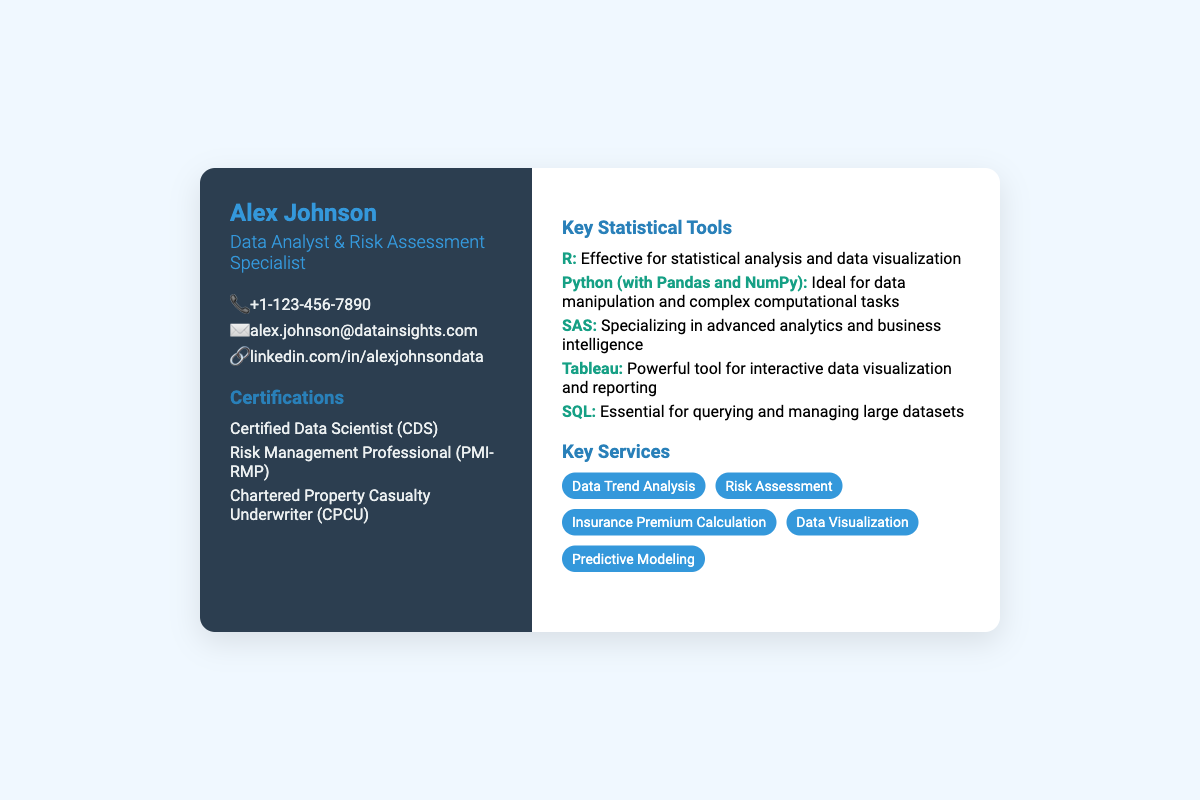What is the name of the individual on the business card? The name of the individual prominently displayed on the card is Alex Johnson.
Answer: Alex Johnson What is Alex Johnson's professional title? The title listed under the name is Data Analyst & Risk Assessment Specialist.
Answer: Data Analyst & Risk Assessment Specialist What is the contact phone number provided? The document includes a phone number, which is specifically stated as "+1-123-456-7890".
Answer: +1-123-456-7890 Which certification indicates expertise in risk management? Among the listed certifications, the one indicating expertise in risk management is the "Risk Management Professional (PMI-RMP)".
Answer: Risk Management Professional (PMI-RMP) How many key statistical tools are mentioned? The document lists a total of five key statistical tools.
Answer: Five Which tool is specifically mentioned for interactive data visualization? The tool identified for interactive data visualization is Tableau.
Answer: Tableau What type of services does Alex Johnson offer? The document lists several services, one of which is Risk Assessment.
Answer: Risk Assessment Which programming language is noted for data manipulation? Among the tools listed, Python (with Pandas and NumPy) is noted for data manipulation.
Answer: Python (with Pandas and NumPy) What is the URL for Alex Johnson's LinkedIn profile? The LinkedIn profile URL provided in the contact information is "linkedin.com/in/alexjohnsondata".
Answer: linkedin.com/in/alexjohnsondata 